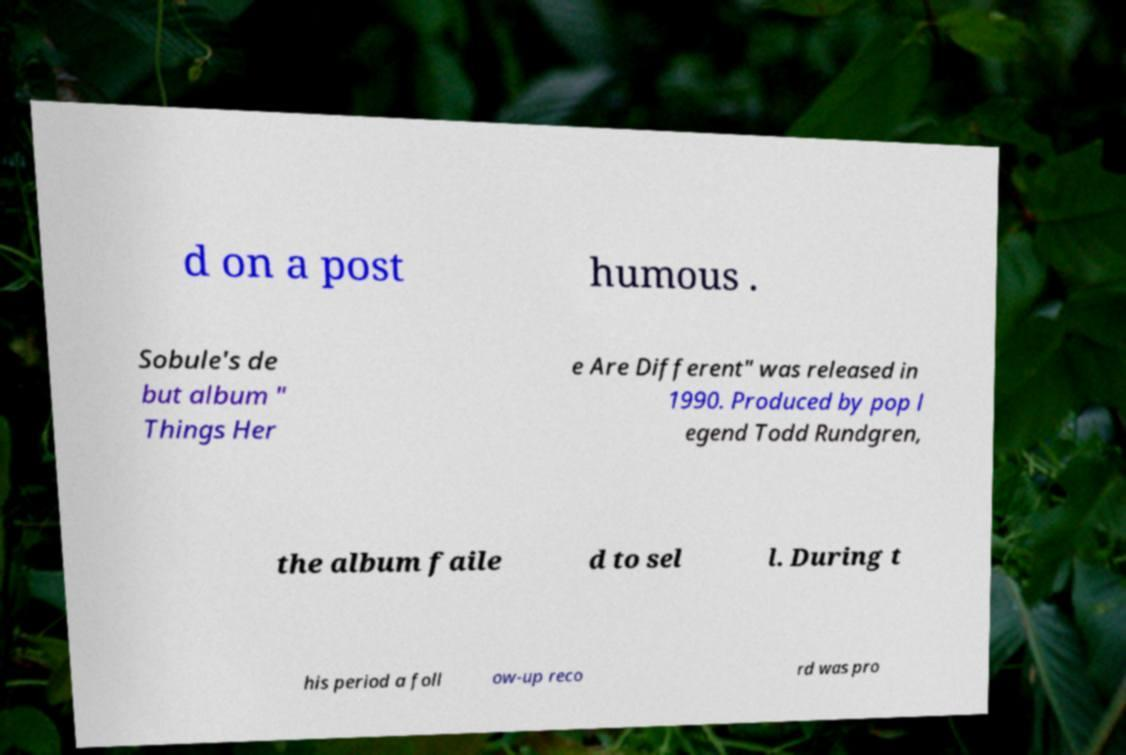What messages or text are displayed in this image? I need them in a readable, typed format. d on a post humous . Sobule's de but album " Things Her e Are Different" was released in 1990. Produced by pop l egend Todd Rundgren, the album faile d to sel l. During t his period a foll ow-up reco rd was pro 